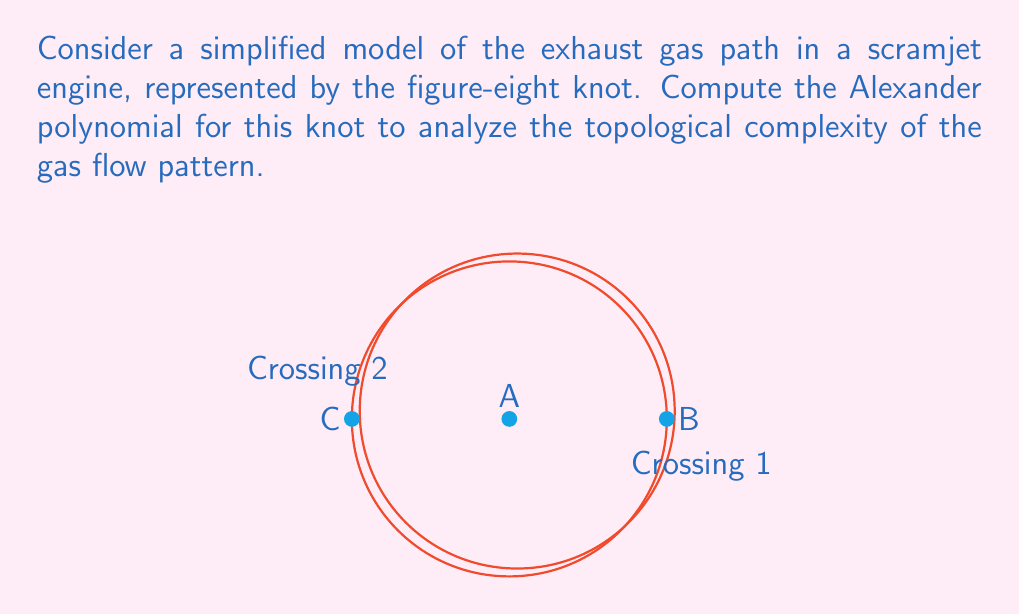Show me your answer to this math problem. To compute the Alexander polynomial for the figure-eight knot, we'll follow these steps:

1) First, we need to create the Alexander matrix. For a knot with n crossings, this matrix will be (n-1) x n.

2) Label the arcs of the knot A, B, and C as shown in the diagram.

3) For each crossing, we'll write an equation:
   Crossing 1: $t A - B + (1-t) C = 0$
   Crossing 2: $t C - A + (1-t) B = 0$

4) From these equations, we can form the Alexander matrix:

   $$
   \begin{pmatrix}
   t & -1 & 1-t \\
   -1 & 1-t & t
   \end{pmatrix}
   $$

5) The Alexander polynomial is the determinant of any (n-1) x (n-1) minor of this matrix, divided by $\pm t^k$ to make it symmetric. Let's choose the minor formed by removing the last column:

   $$
   \begin{vmatrix}
   t & -1 \\
   -1 & 1-t
   \end{vmatrix}
   $$

6) Calculate the determinant:
   $\Delta(t) = t(1-t) - (-1)(-1) = t - t^2 - 1$

7) To make it symmetric, we multiply by -t:
   $\Delta(t) = -t(t - t^2 - 1) = -t^3 + t^2 + t$

8) The final Alexander polynomial is:
   $\Delta(t) = t^3 - t^2 - t + 1$

This polynomial provides insights into the topological complexity of the exhaust gas flow pattern in the scramjet engine model.
Answer: $\Delta(t) = t^3 - t^2 - t + 1$ 